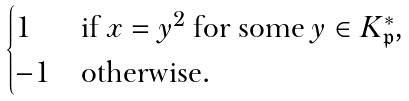Convert formula to latex. <formula><loc_0><loc_0><loc_500><loc_500>\begin{cases} 1 & \text {if $x = y^{2}$ for some $y\in K_{\mathfrak{p}}^{*}$,} \\ - 1 & \text {otherwise.} \end{cases}</formula> 